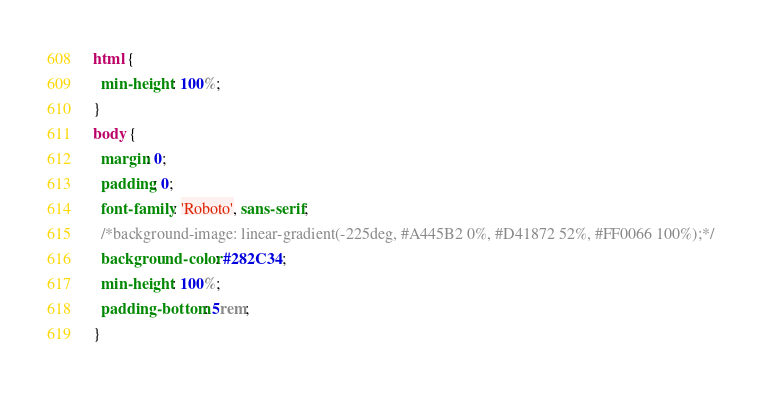Convert code to text. <code><loc_0><loc_0><loc_500><loc_500><_CSS_>html {
  min-height: 100%;
}
body {
  margin: 0;
  padding: 0;
  font-family: 'Roboto', sans-serif;
  /*background-image: linear-gradient(-225deg, #A445B2 0%, #D41872 52%, #FF0066 100%);*/
  background-color: #282C34;
  min-height: 100%;
  padding-bottom: 5rem;
}
</code> 